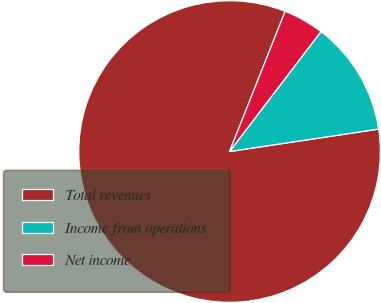Convert chart to OTSL. <chart><loc_0><loc_0><loc_500><loc_500><pie_chart><fcel>Total revenues<fcel>Income from operations<fcel>Net income<nl><fcel>83.38%<fcel>12.26%<fcel>4.36%<nl></chart> 